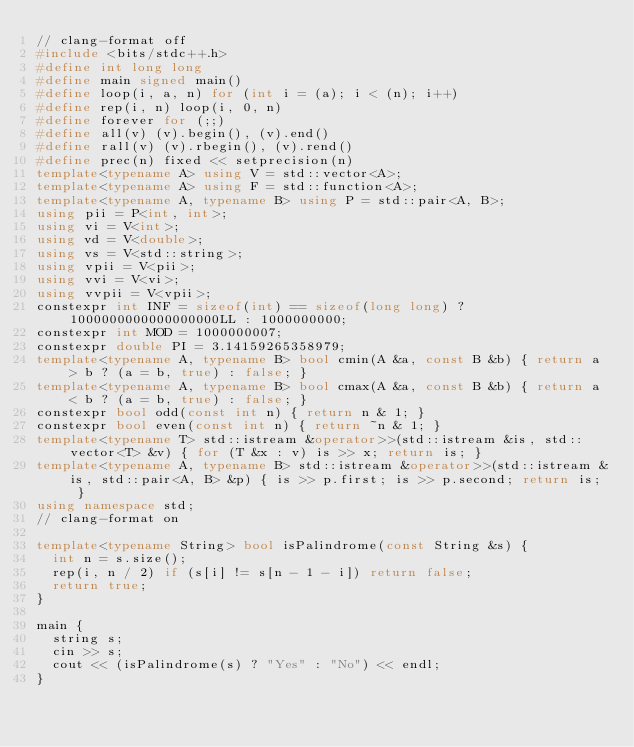Convert code to text. <code><loc_0><loc_0><loc_500><loc_500><_C++_>// clang-format off
#include <bits/stdc++.h>
#define int long long
#define main signed main()
#define loop(i, a, n) for (int i = (a); i < (n); i++)
#define rep(i, n) loop(i, 0, n)
#define forever for (;;)
#define all(v) (v).begin(), (v).end()
#define rall(v) (v).rbegin(), (v).rend()
#define prec(n) fixed << setprecision(n)
template<typename A> using V = std::vector<A>;
template<typename A> using F = std::function<A>;
template<typename A, typename B> using P = std::pair<A, B>;
using pii = P<int, int>;
using vi = V<int>;
using vd = V<double>;
using vs = V<std::string>;
using vpii = V<pii>;
using vvi = V<vi>;
using vvpii = V<vpii>;
constexpr int INF = sizeof(int) == sizeof(long long) ? 1000000000000000000LL : 1000000000;
constexpr int MOD = 1000000007;
constexpr double PI = 3.14159265358979;
template<typename A, typename B> bool cmin(A &a, const B &b) { return a > b ? (a = b, true) : false; }
template<typename A, typename B> bool cmax(A &a, const B &b) { return a < b ? (a = b, true) : false; }
constexpr bool odd(const int n) { return n & 1; }
constexpr bool even(const int n) { return ~n & 1; }
template<typename T> std::istream &operator>>(std::istream &is, std::vector<T> &v) { for (T &x : v) is >> x; return is; }
template<typename A, typename B> std::istream &operator>>(std::istream &is, std::pair<A, B> &p) { is >> p.first; is >> p.second; return is; }
using namespace std;
// clang-format on

template<typename String> bool isPalindrome(const String &s) {
  int n = s.size();
  rep(i, n / 2) if (s[i] != s[n - 1 - i]) return false;
  return true;
}

main {
  string s;
  cin >> s;
  cout << (isPalindrome(s) ? "Yes" : "No") << endl;
}
</code> 